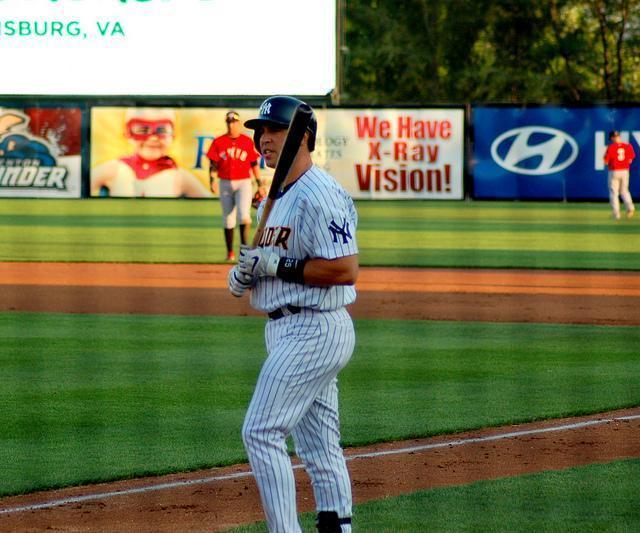How many people are there?
Give a very brief answer. 2. 